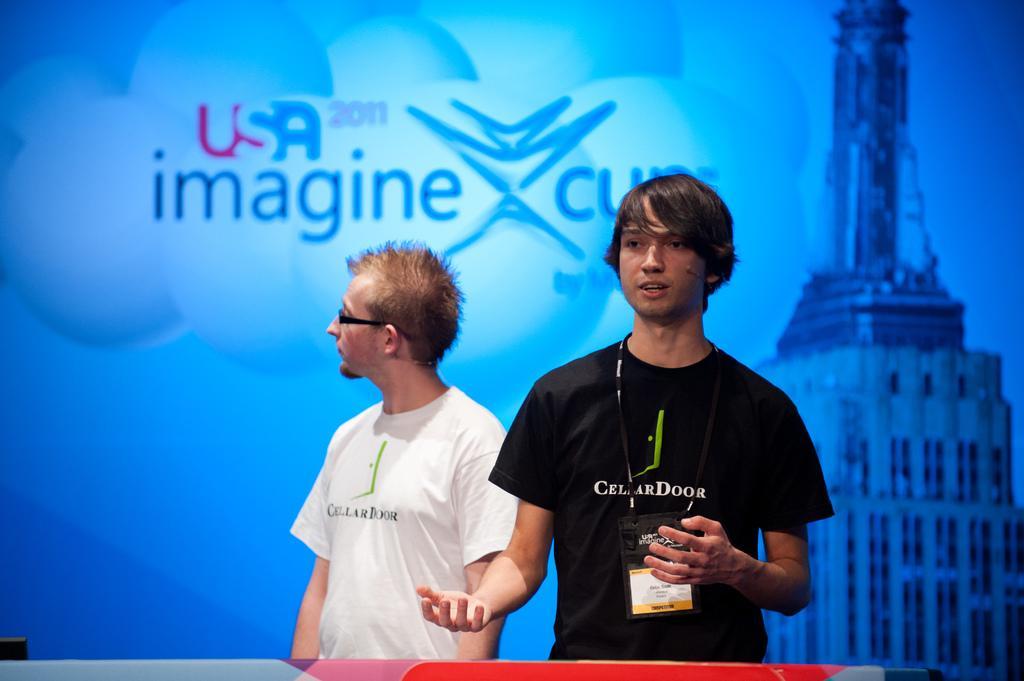Describe this image in one or two sentences. In the image there is a man standing and there is an identity card with tag around his neck. Behind him there is a man with spectacles is standing. Behind them there is a poster with an image and something written on it. 